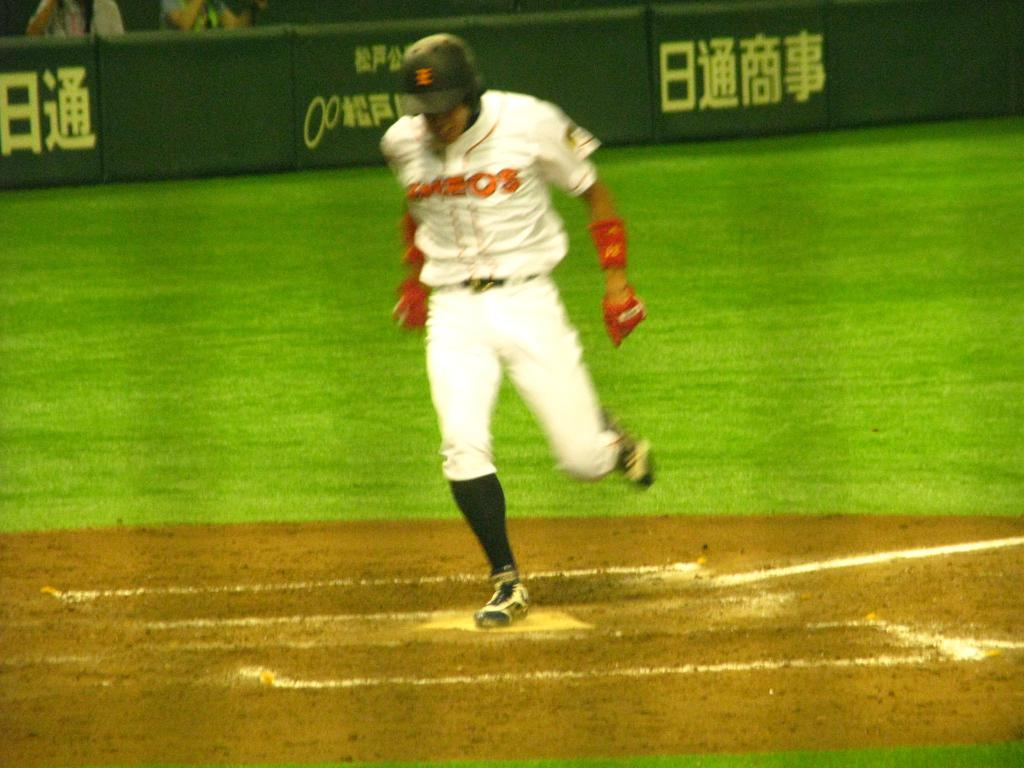<image>
Offer a succinct explanation of the picture presented. a person running with Japanese writing behind them 